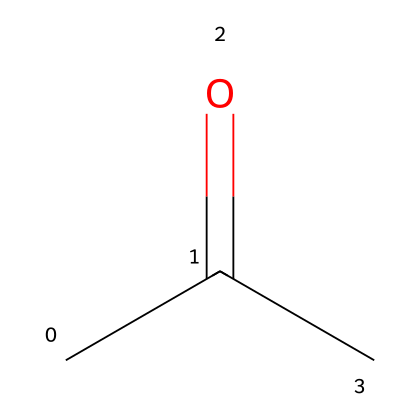What is the molecular formula of this compound? The compound's structure reveals a total of three carbon atoms, six hydrogen atoms, and one oxygen atom. Therefore, the molecular formula is C3H6O.
Answer: C3H6O How many carbon atoms are present in this molecule? By examining the structure, there are three distinct carbon atoms (the two methyl groups and the carbonyl carbon).
Answer: 3 What type of molecular geometry does acetone have? The central carbon atom bonded to the carbonyl oxygen exhibits a trigonal planar geometry due to sp2 hybridization, while the methyl groups adopt a tetrahedral arrangement around their respective carbon atoms.
Answer: trigonal planar Is this solvent polar or nonpolar? The presence of a carbonyl group creates a significant dipole moment due to the electronegativity difference between carbon and oxygen, making acetone polar.
Answer: polar What type of solvent is acetone? Acetone is classified as a polar aprotic solvent, which is characterized by its ability to solvate cations without donating hydrogen bonds to anions.
Answer: polar aprotic How many double bonds are in this molecule? The structure includes one double bond between the carbon and oxygen atoms in the carbonyl group.
Answer: 1 What is the role of acetone in organic reactions? Acetone often acts as a solvent in organic reactions, aiding in dissolution and facilitating reactions due to its polar nature and ability to stabilize ionic species.
Answer: solvent 